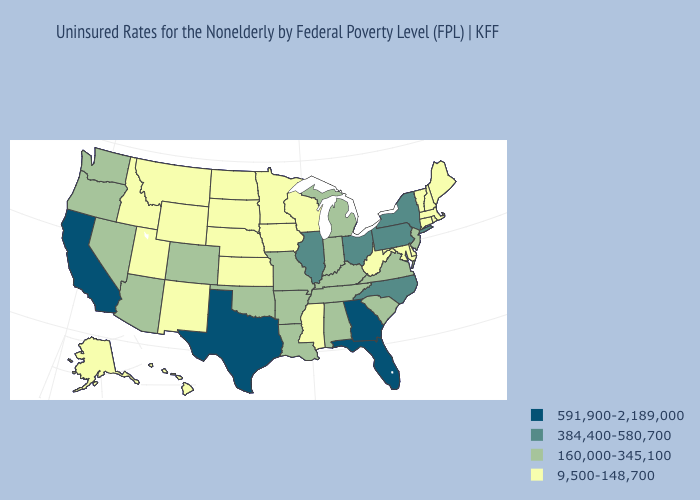Name the states that have a value in the range 160,000-345,100?
Keep it brief. Alabama, Arizona, Arkansas, Colorado, Indiana, Kentucky, Louisiana, Michigan, Missouri, Nevada, New Jersey, Oklahoma, Oregon, South Carolina, Tennessee, Virginia, Washington. Does Texas have a higher value than Minnesota?
Short answer required. Yes. Among the states that border Wyoming , does Colorado have the lowest value?
Answer briefly. No. Name the states that have a value in the range 160,000-345,100?
Answer briefly. Alabama, Arizona, Arkansas, Colorado, Indiana, Kentucky, Louisiana, Michigan, Missouri, Nevada, New Jersey, Oklahoma, Oregon, South Carolina, Tennessee, Virginia, Washington. Does the map have missing data?
Short answer required. No. Which states hav the highest value in the Northeast?
Concise answer only. New York, Pennsylvania. Name the states that have a value in the range 9,500-148,700?
Quick response, please. Alaska, Connecticut, Delaware, Hawaii, Idaho, Iowa, Kansas, Maine, Maryland, Massachusetts, Minnesota, Mississippi, Montana, Nebraska, New Hampshire, New Mexico, North Dakota, Rhode Island, South Dakota, Utah, Vermont, West Virginia, Wisconsin, Wyoming. Does Vermont have the highest value in the Northeast?
Give a very brief answer. No. Does Alabama have the same value as Kentucky?
Concise answer only. Yes. What is the value of Hawaii?
Write a very short answer. 9,500-148,700. Does the first symbol in the legend represent the smallest category?
Answer briefly. No. Which states hav the highest value in the Northeast?
Concise answer only. New York, Pennsylvania. What is the value of Oregon?
Concise answer only. 160,000-345,100. Name the states that have a value in the range 160,000-345,100?
Be succinct. Alabama, Arizona, Arkansas, Colorado, Indiana, Kentucky, Louisiana, Michigan, Missouri, Nevada, New Jersey, Oklahoma, Oregon, South Carolina, Tennessee, Virginia, Washington. Which states have the lowest value in the Northeast?
Short answer required. Connecticut, Maine, Massachusetts, New Hampshire, Rhode Island, Vermont. 